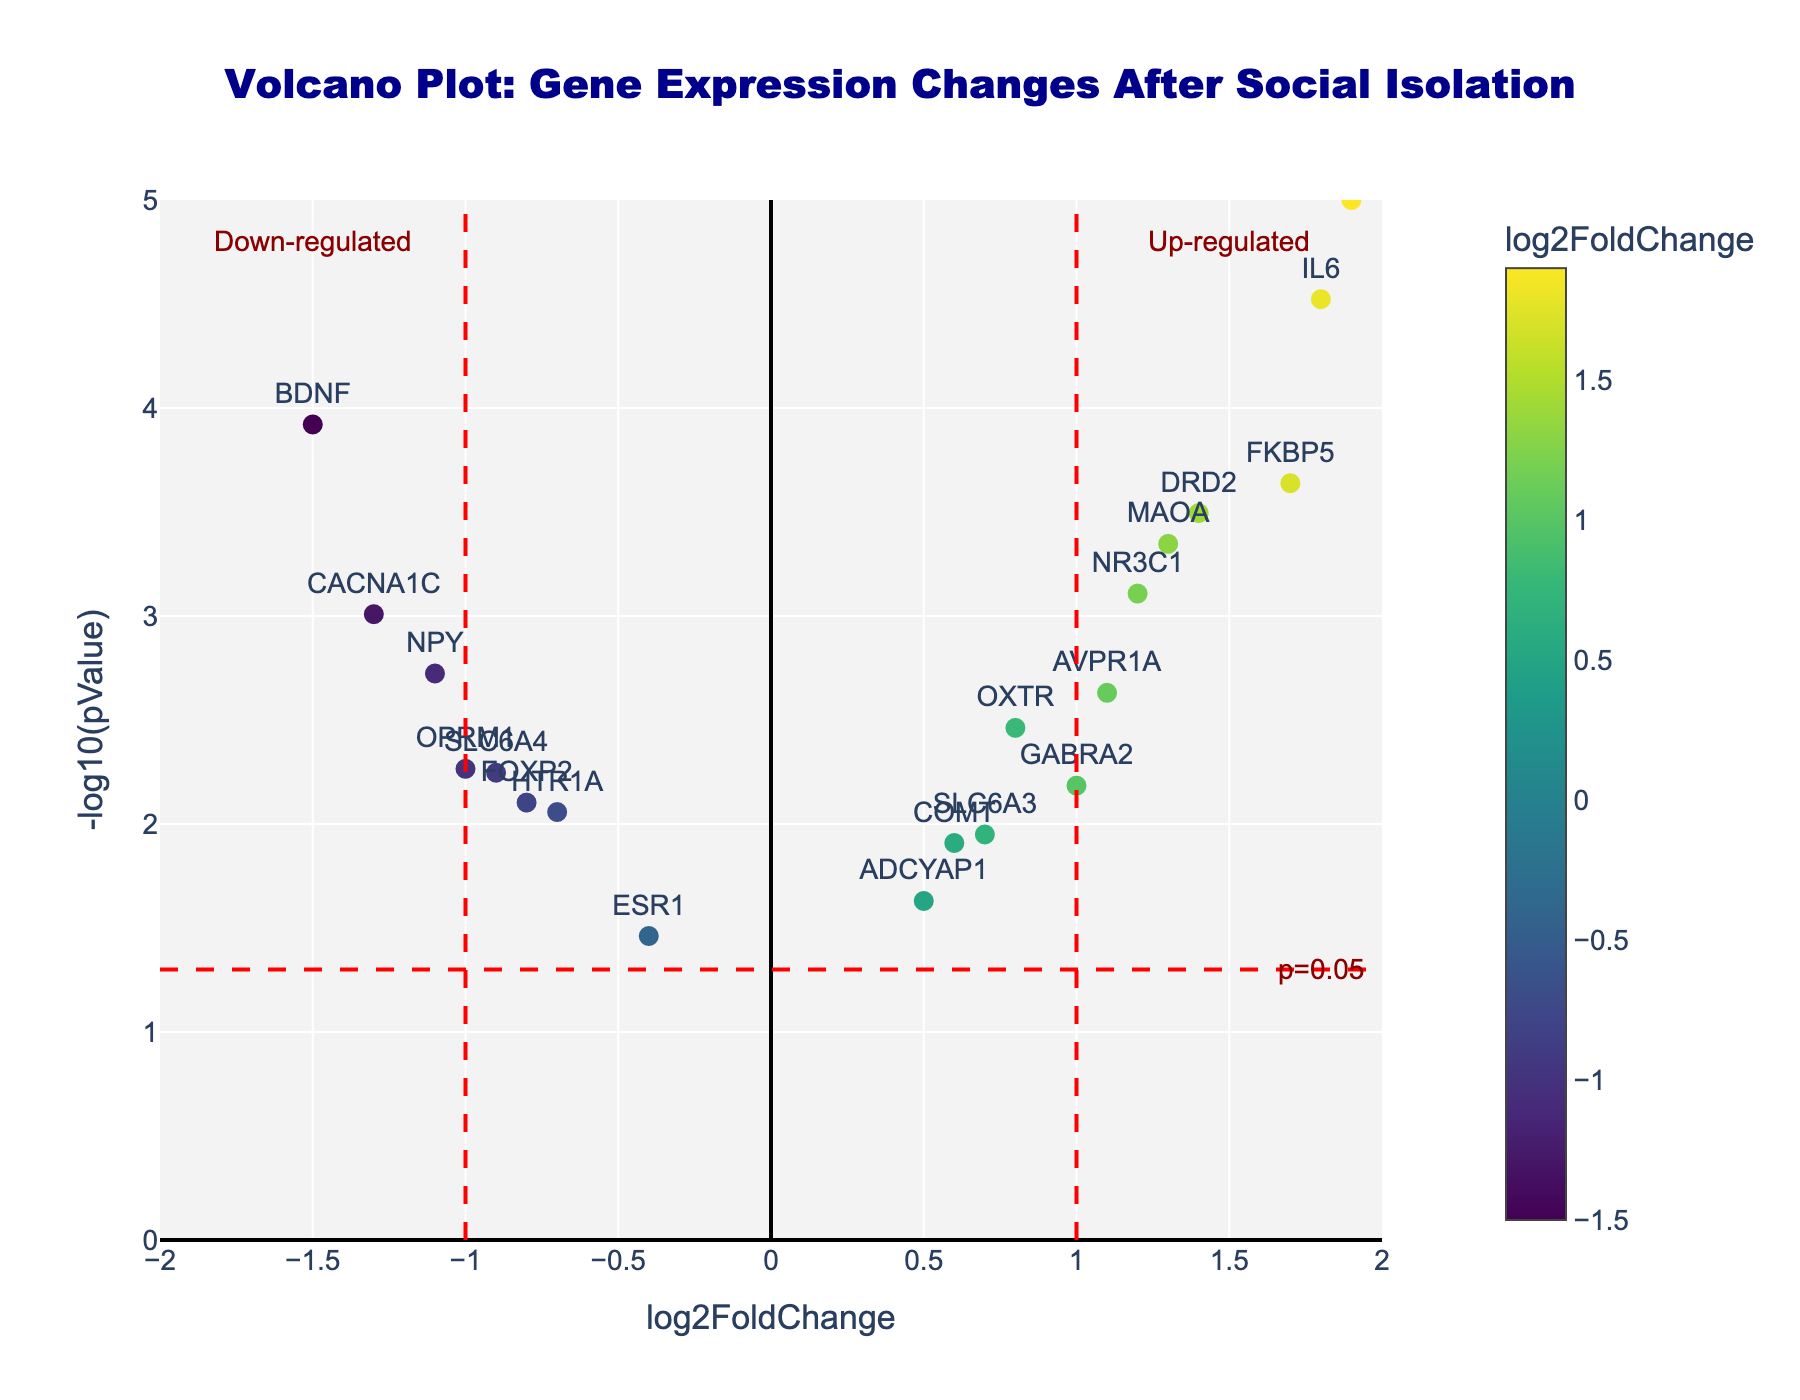What is the title of the plot? The title is centered at the top of the plot and reads "Volcano Plot: Gene Expression Changes After Social Isolation". This can be seen in the large, bold text.
Answer: Volcano Plot: Gene Expression Changes After Social Isolation Which gene has the highest log2FoldChange? The gene with the highest log2FoldChange is the one located furthest to the right on the x-axis. Based on the plot, CRH has the highest log2FoldChange.
Answer: CRH How many genes are up-regulated and have significant p-values (p < 0.05)? Up-regulated genes have positive log2FoldChange values, and significant p-values are below the red horizontal line (p = 0.05). The genes that meet these criteria are OXTR, NR3C1, FKBP5, MAOA, CRH, GABRA2, DRD2, AVPR1A, and IL6. There are 9 such genes.
Answer: 9 What is the approximate p-value threshold depicted in the volcano plot? The p-value threshold is denoted by the red horizontal line. Since this line is labeled "p=0.05", the threshold is 0.05.
Answer: 0.05 Which gene is displayed furthest to the left on the plot? The gene located furthest to the left on the x-axis has the most negative log2FoldChange. According to the plot, BDNF is the furthest to the left.
Answer: BDNF Among the genes with negative log2FoldChange, which has the smallest p-value? Among the negatively regulated genes, find the one that is highest on the y-axis (indicating the smallest p-value). CACNA1C has the highest -log10(pValue) among genes with negative log2FoldChange.
Answer: CACNA1C Which genes fall outside the log2FoldChange thresholds of -1 and 1? Genes outside these thresholds are those that lie beyond the vertical red dashed lines. These are BDNF, CACNA1C, FKBP5, CRH, and IL6.
Answer: BDNF, CACNA1C, FKBP5, CRH, IL6 How many genes are down-regulated and have significant p-values (p < 0.05)? Down-regulated genes have negative log2FoldChange values, and significant p-values are below the red horizontal line. The genes that meet these criteria are BDNF, NPY, and CACNA1C. There are 3 such genes.
Answer: 3 Which gene has the highest -log10(pValue)? The -log10(pValue) is represented on the y-axis. The gene highest on this axis has the smallest p-value. IL6 is the highest on the y-axis, indicating the highest -log10(pValue).
Answer: IL6 